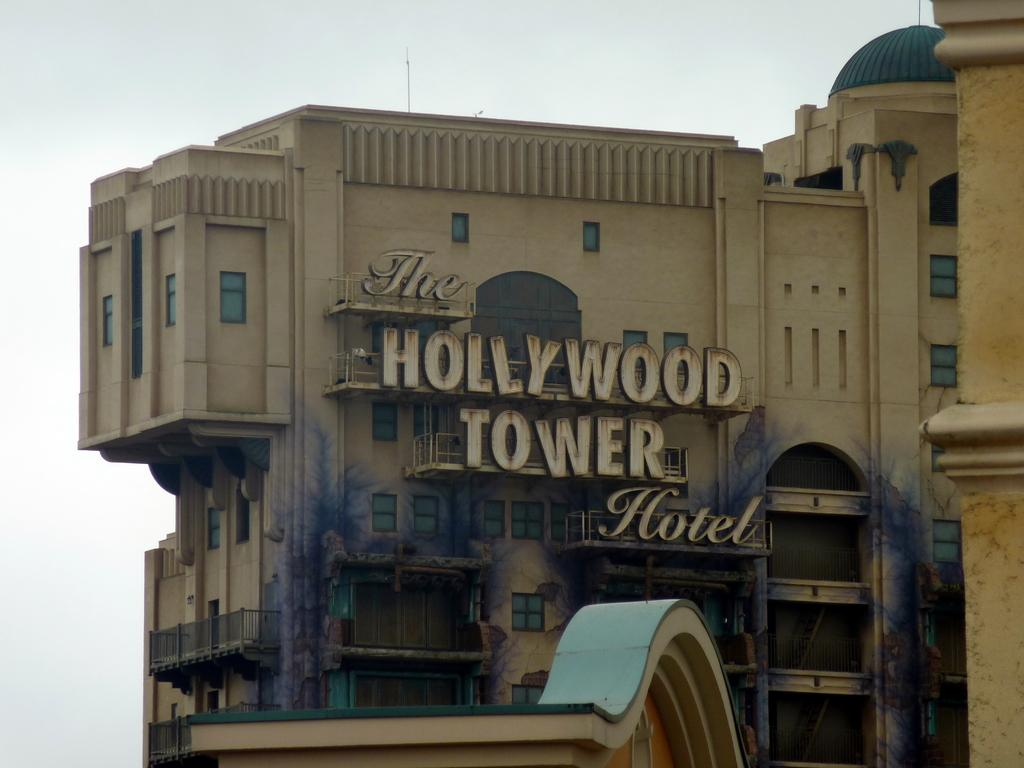<image>
Present a compact description of the photo's key features. The Hollywood Tower Hotel under a bright blue sky. 